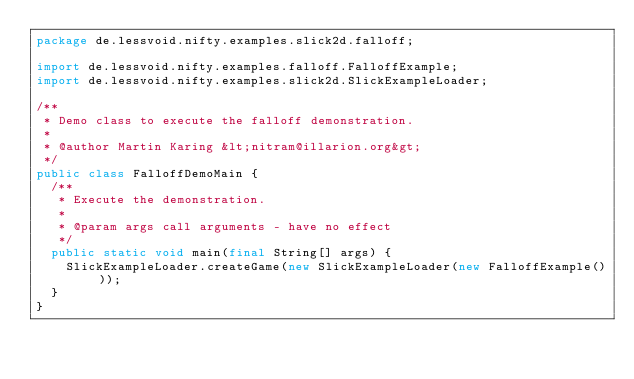<code> <loc_0><loc_0><loc_500><loc_500><_Java_>package de.lessvoid.nifty.examples.slick2d.falloff;

import de.lessvoid.nifty.examples.falloff.FalloffExample;
import de.lessvoid.nifty.examples.slick2d.SlickExampleLoader;

/**
 * Demo class to execute the falloff demonstration.
 *
 * @author Martin Karing &lt;nitram@illarion.org&gt;
 */
public class FalloffDemoMain {
  /**
   * Execute the demonstration.
   *
   * @param args call arguments - have no effect
   */
  public static void main(final String[] args) {
    SlickExampleLoader.createGame(new SlickExampleLoader(new FalloffExample()));
  }
}
</code> 